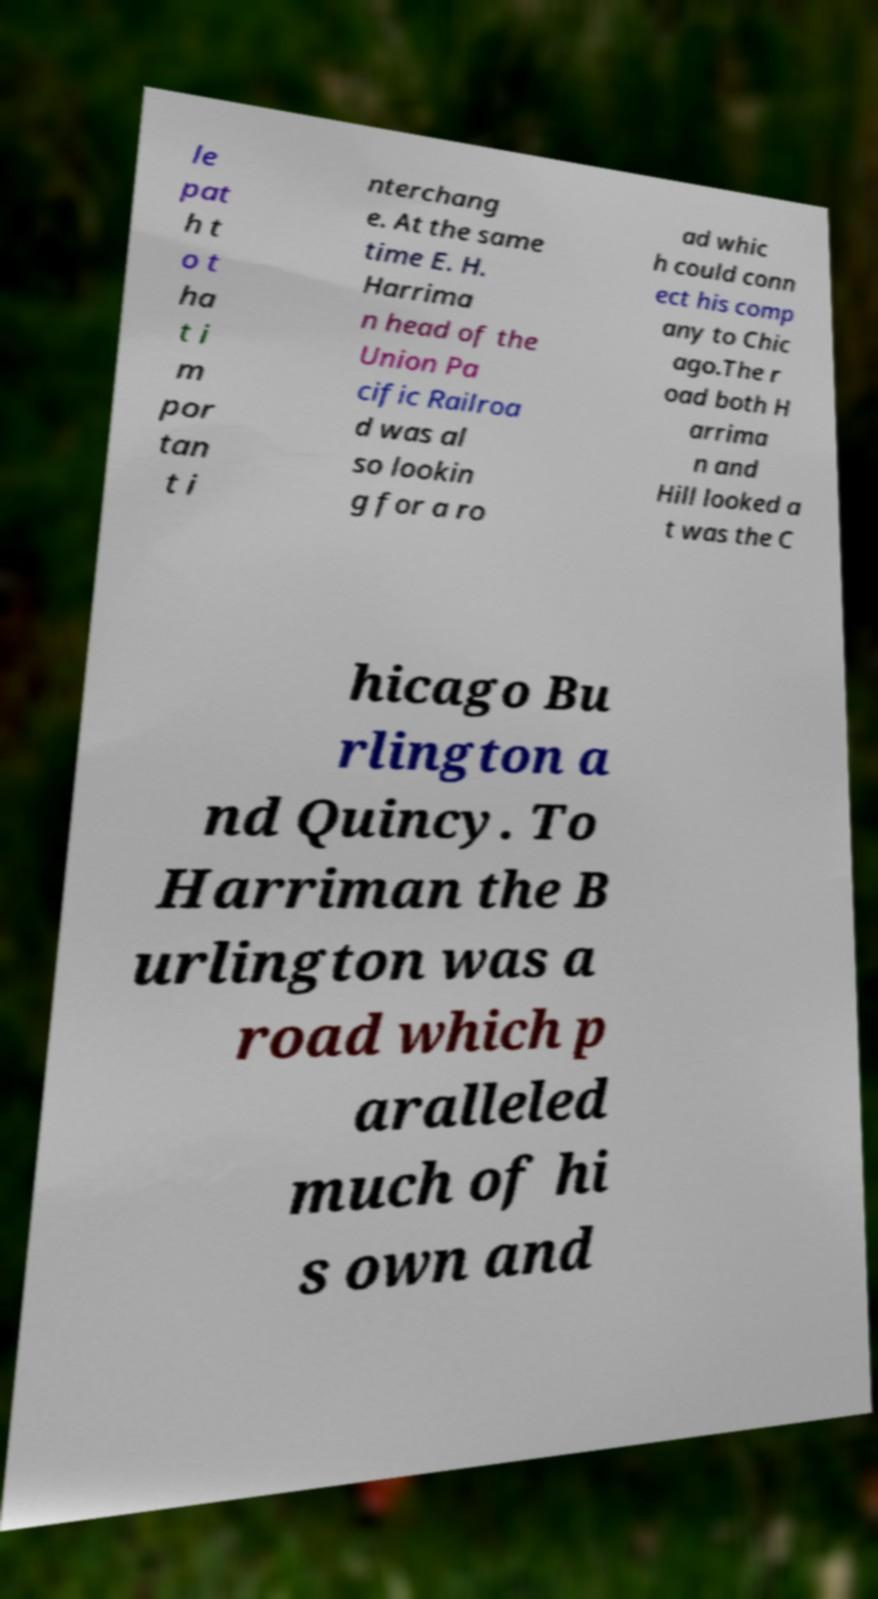Please identify and transcribe the text found in this image. le pat h t o t ha t i m por tan t i nterchang e. At the same time E. H. Harrima n head of the Union Pa cific Railroa d was al so lookin g for a ro ad whic h could conn ect his comp any to Chic ago.The r oad both H arrima n and Hill looked a t was the C hicago Bu rlington a nd Quincy. To Harriman the B urlington was a road which p aralleled much of hi s own and 